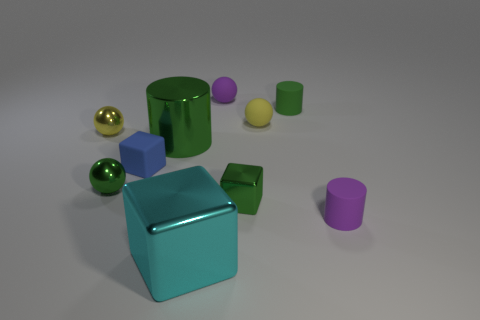Subtract all tiny purple matte spheres. How many spheres are left? 3 Subtract all purple spheres. How many spheres are left? 3 Subtract all red spheres. Subtract all brown cubes. How many spheres are left? 4 Subtract all balls. How many objects are left? 6 Add 9 cyan things. How many cyan things exist? 10 Subtract 0 gray balls. How many objects are left? 10 Subtract all big blocks. Subtract all yellow spheres. How many objects are left? 7 Add 3 rubber blocks. How many rubber blocks are left? 4 